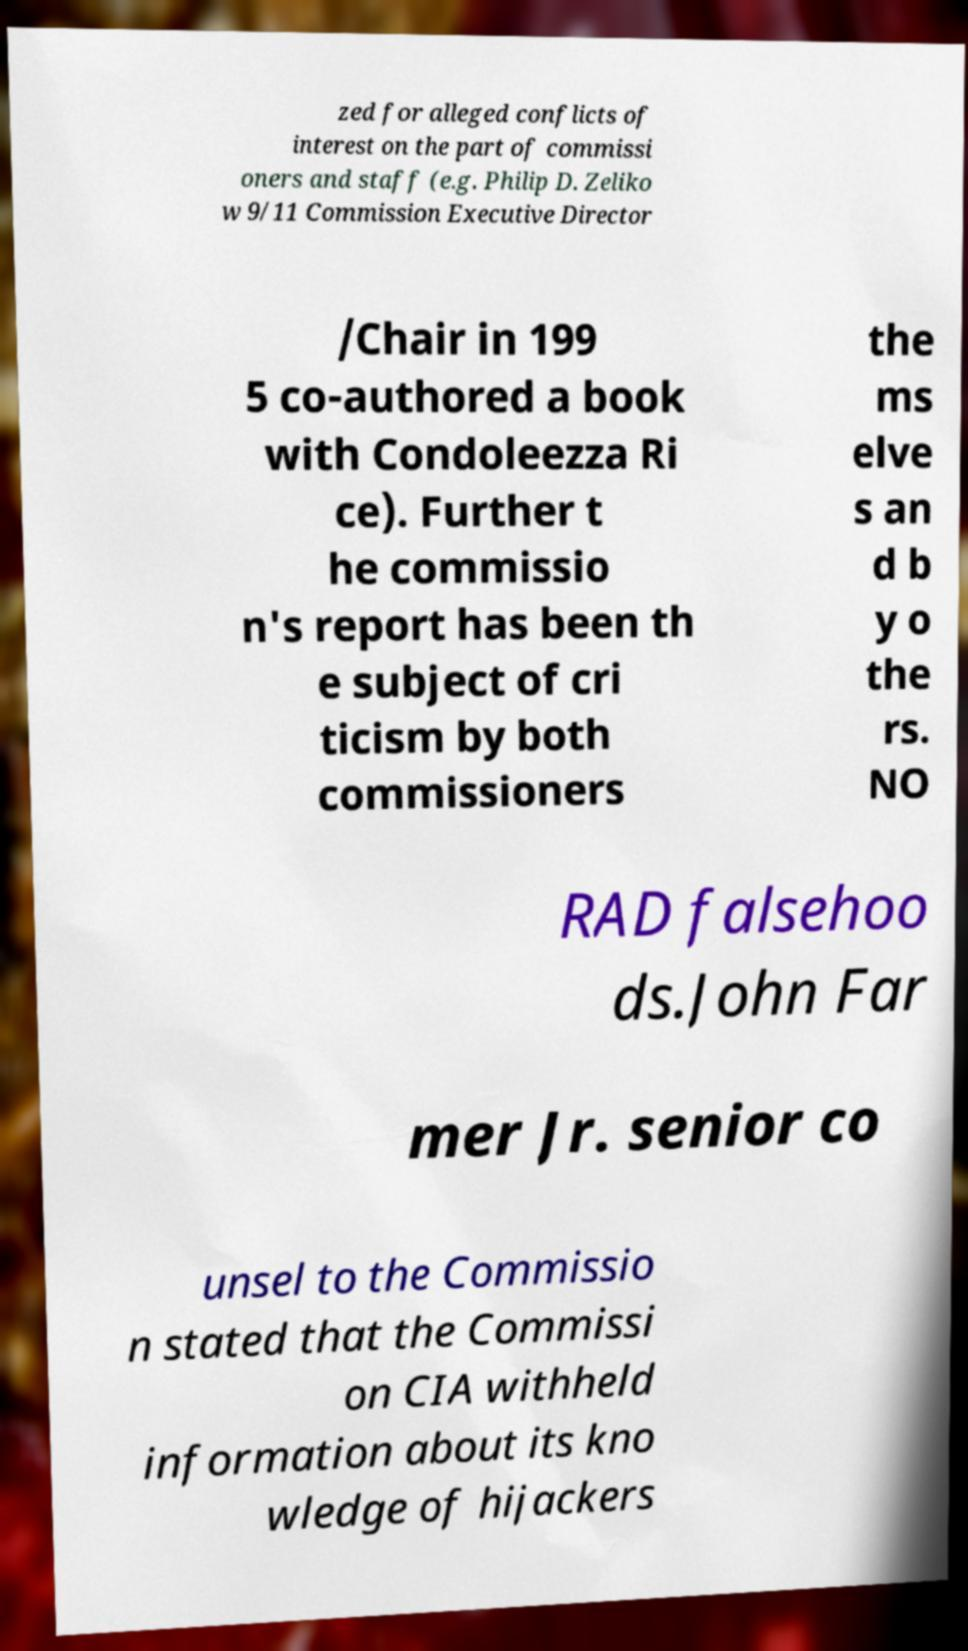Can you accurately transcribe the text from the provided image for me? zed for alleged conflicts of interest on the part of commissi oners and staff (e.g. Philip D. Zeliko w 9/11 Commission Executive Director /Chair in 199 5 co-authored a book with Condoleezza Ri ce). Further t he commissio n's report has been th e subject of cri ticism by both commissioners the ms elve s an d b y o the rs. NO RAD falsehoo ds.John Far mer Jr. senior co unsel to the Commissio n stated that the Commissi on CIA withheld information about its kno wledge of hijackers 